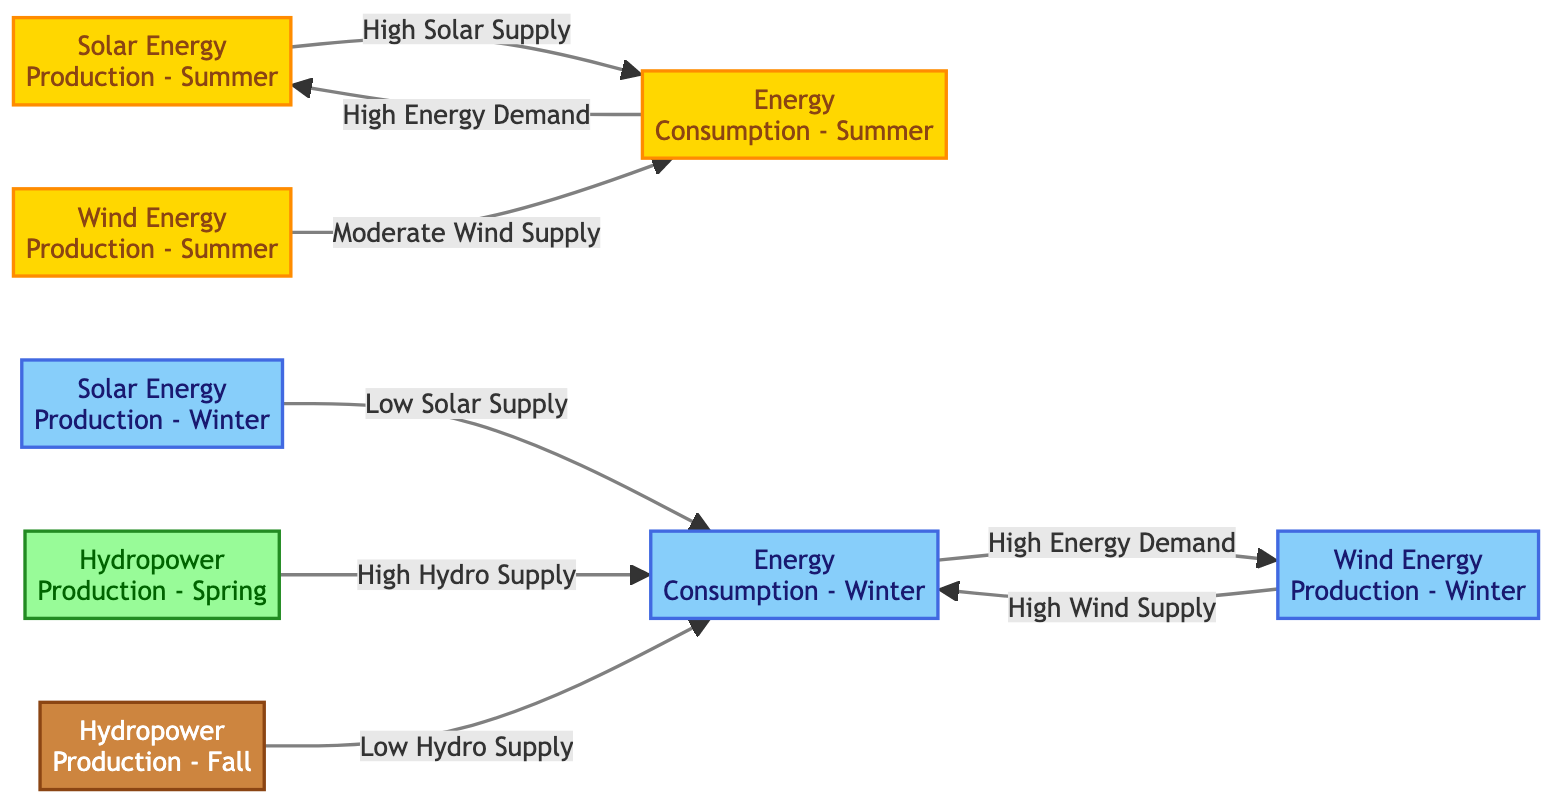What is the energy production during summer for solar energy? The diagram indicates that the energy production for solar energy during summer is labeled as "Solar Energy Production - Summer". It is situated at the summer node colored in gold, denoting that it refers to solar energy output specific to the summer season.
Answer: Solar Energy Production - Summer How does wind energy production in summer relate to energy consumption in summer? The diagram shows a direct connection from "Wind Energy Production - Summer" to "Energy Consumption - Summer". The relationship indicates that there is a moderate wind supply available during the summer months to meet energy consumption demands, highlighting a connection between production and consumption in this season.
Answer: Moderate Wind Supply Which season has low solar energy production? From the diagram, winter is associated with "Solar Energy Production - Winter," which is noted for having low solar energy output. The winter node is painted light blue, symbolizing the lack of sunlight during this season compared to summer.
Answer: Winter What is the hydro power production during spring? The diagram indicates "Hydropower Production - Spring" that corresponds to high hydro supply in spring. This information is depicted at the spring node, which is colored light green, signifying the availability of hydro energy during this specific season.
Answer: High Hydro Supply Which energy source has a high supply in winter? The diagram connects "Hydropower Production - Spring" towards "Energy Consumption - Winter," suggesting a source of energy supply during winter. There is no direct mention of high supply in winter for other energy forms in the flowchart, thus indicating that the winter season relies on hydro energy.
Answer: Hydro Supply What is the relationship between energy consumption in summer and solar energy production? The diagram illustrates that "Energy Consumption - Summer" is directly linked to "Solar Energy Production - Summer," indicating a strong dependence where high energy demand during summer correlates with high solar energy supply. This shows the synergy between consumption and production in this season.
Answer: High Energy Demand How many nodes represent energy production in this diagram? By counting the labeled nodes in the diagram, there are four distinct nodes representing energy production – two for solar (summer and winter), one for wind (summer and winter), and two for hydropower (spring and fall). This sums up to a total count of four energy production nodes.
Answer: Four Nodes What is the overall trend for wind energy production in winter? The diagram specifies that "Wind Energy Production - Winter" shows a high supply that satisfies energy consumption needs during this cold season. The indication is clear that wind energy production peaks in winter as shown through the colored winter node.
Answer: High Wind Supply How does energy consumption change from summer to winter based on the diagram? The diagram emphasizes high energy consumption in both summer and winter with varying energy sources adapted to meet these demands. In summer, solar and wind contribute significantly, while in winter, wind and hydropower provide the necessary energy. This reflects a shift in energy sourcing from summer to winter to meet energy needs.
Answer: Shifts in Energy Sourcing 